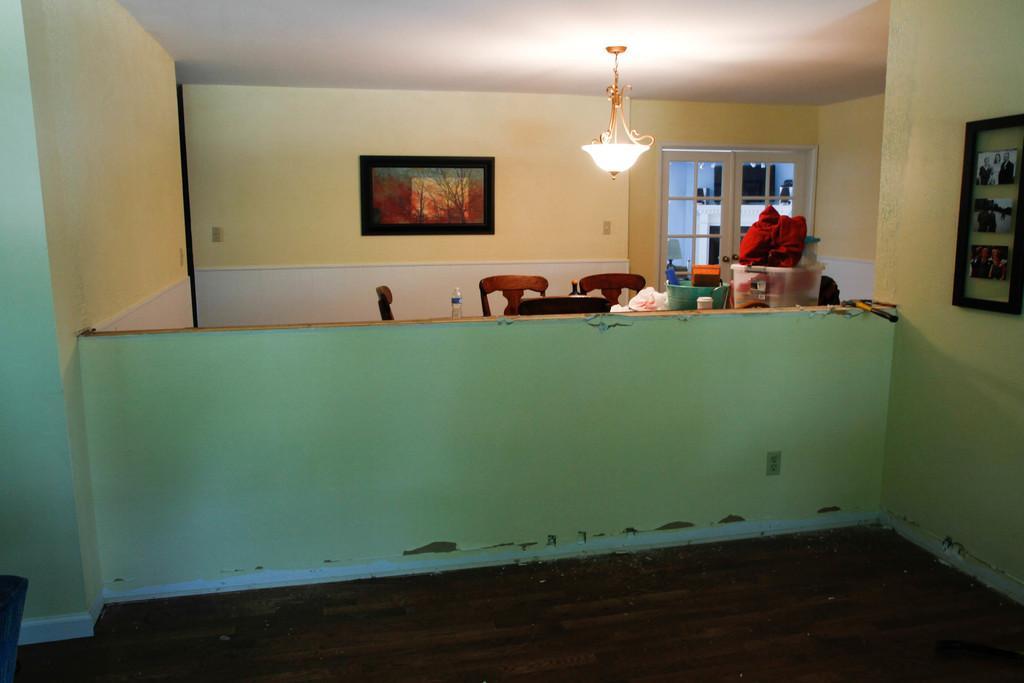How would you summarize this image in a sentence or two? In a given picture there is a room which is well furnished with chairs, table, bottle and some luggage here. There is a photo frame to the wall. We can observe a light from the ceiling which is called chandelier. There is a small wall in the middle. To the right there is a photo frame. And in the background we can observe a door here. 